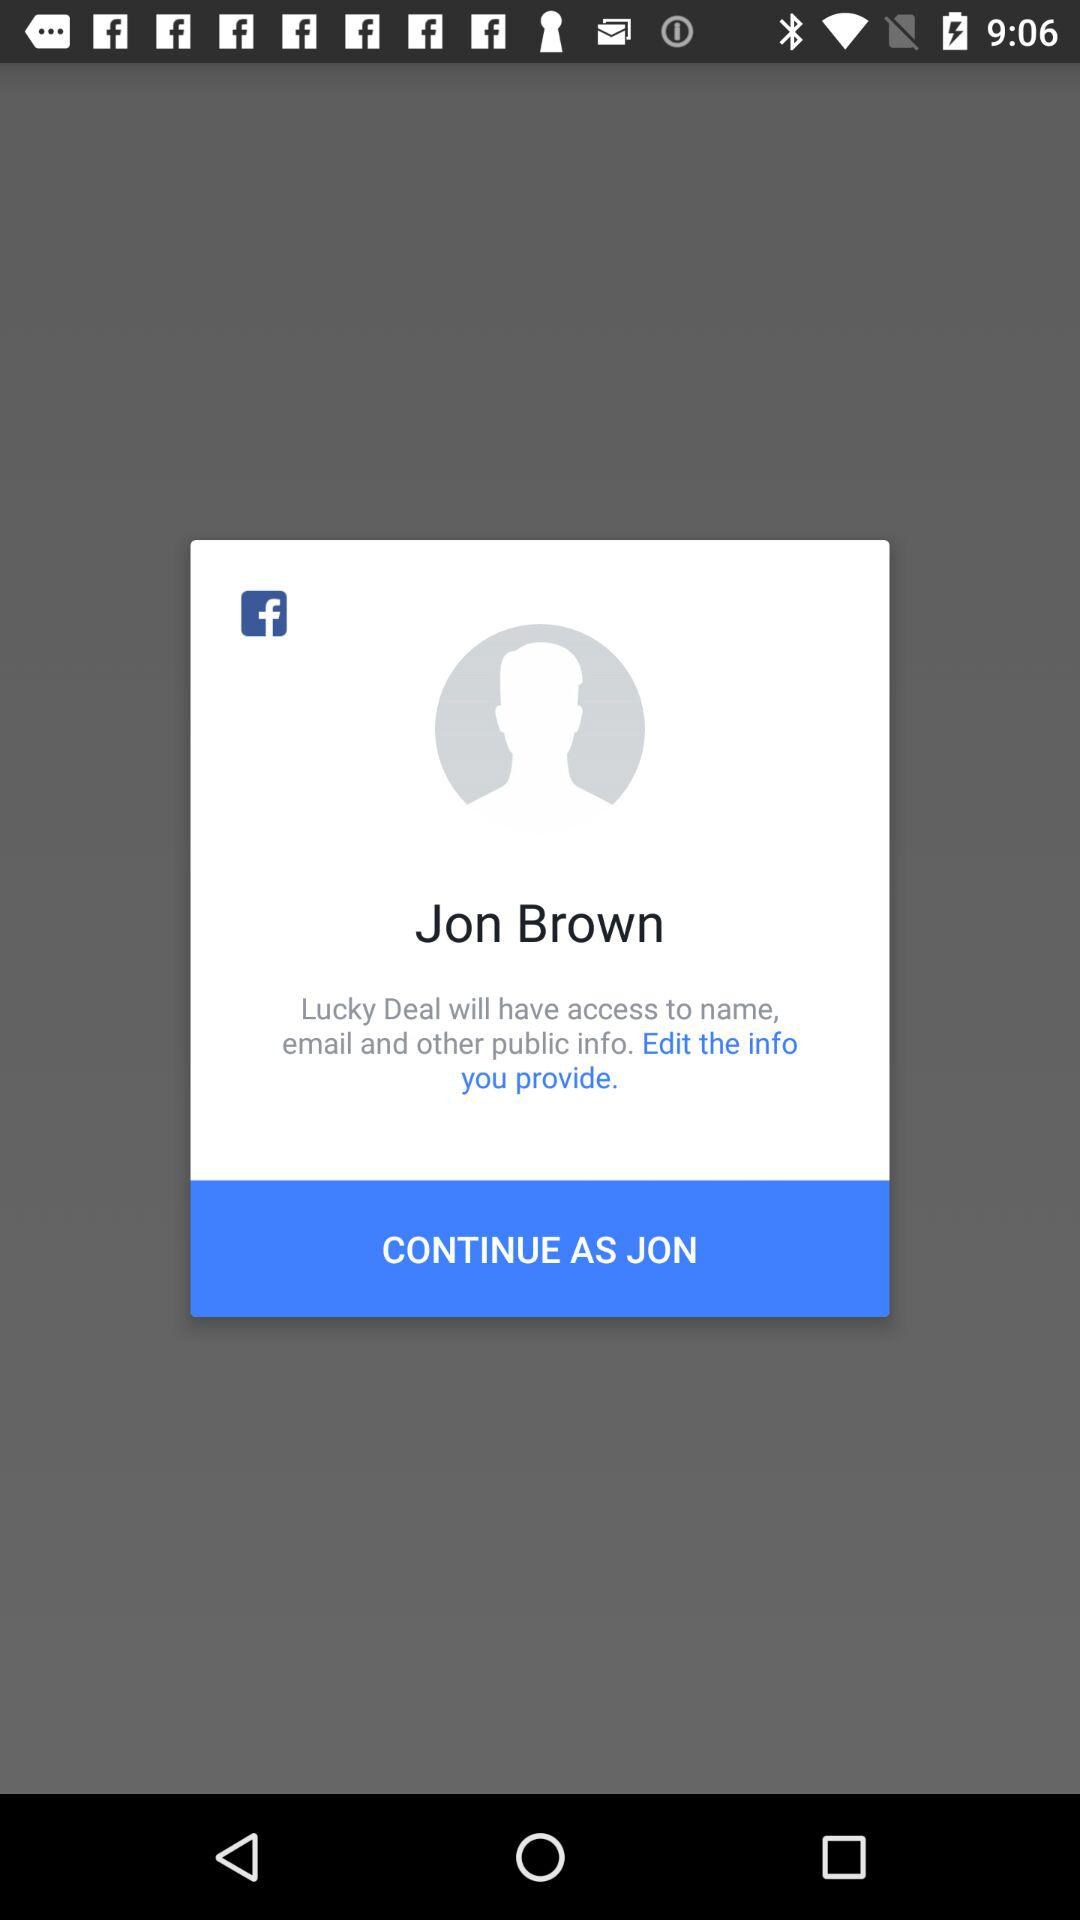What is the user name? The user name is Jon Brown. 